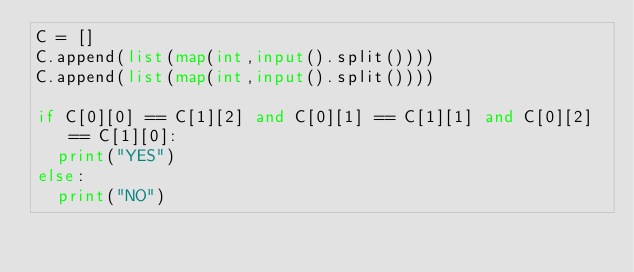Convert code to text. <code><loc_0><loc_0><loc_500><loc_500><_Python_>C = []
C.append(list(map(int,input().split())))
C.append(list(map(int,input().split())))

if C[0][0] == C[1][2] and C[0][1] == C[1][1] and C[0][2] == C[1][0]:
  print("YES")
else:
  print("NO")</code> 